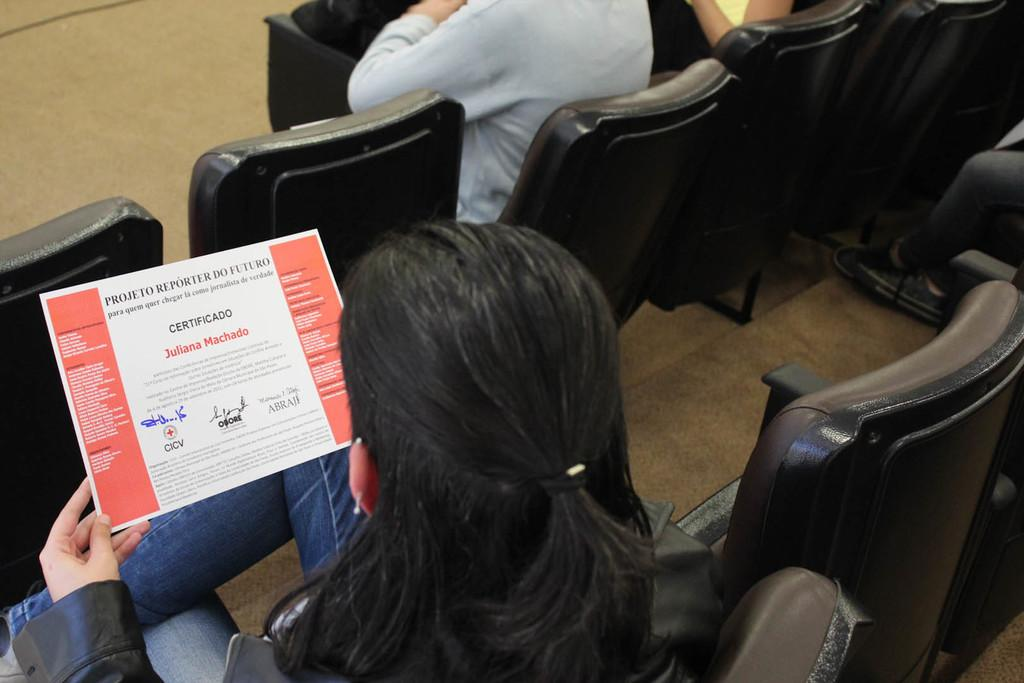What is the woman in the image doing? The woman is sitting on a chair and looking at a paper. Can you describe the position of the woman in relation to another person in the image? There is a person sitting on a chair in front of the woman. What type of cow can be seen in the background of the image? There is no cow present in the image. 